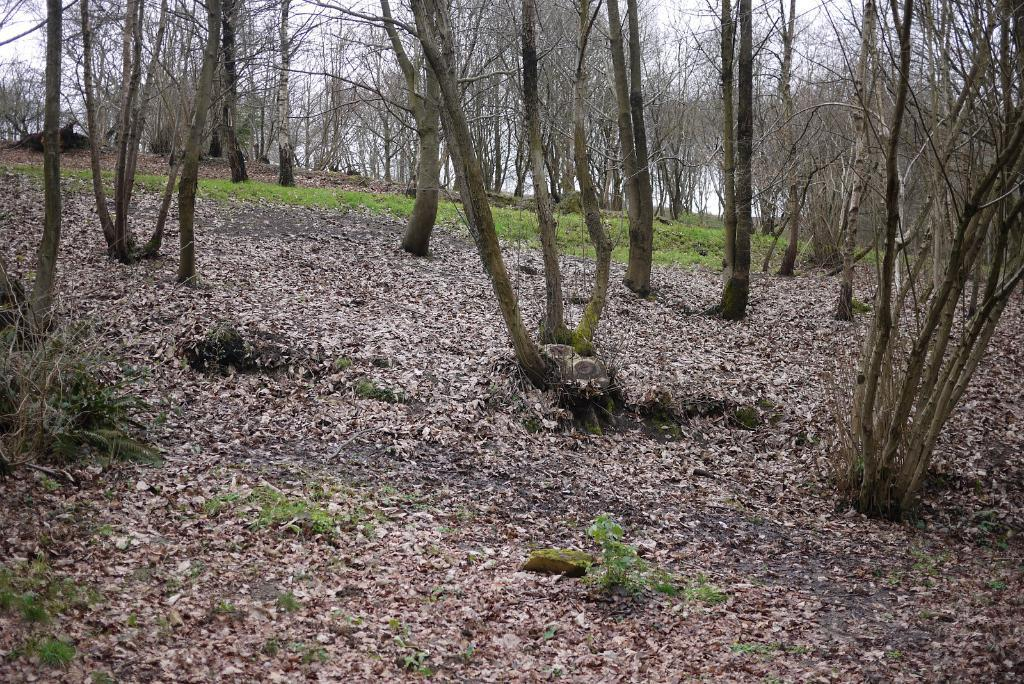What type of vegetation can be seen in the image? There is grass and plants in the image. What is the condition of the leaves in the image? Dried leaves are present in the image. What type of trees can be seen in the image? There are bare trees in the image. What is visible in the background of the image? The sky is visible in the background of the image. Where can the bead be found in the image? There is no bead present in the image. What type of lake can be seen in the image? There is no lake present in the image. 